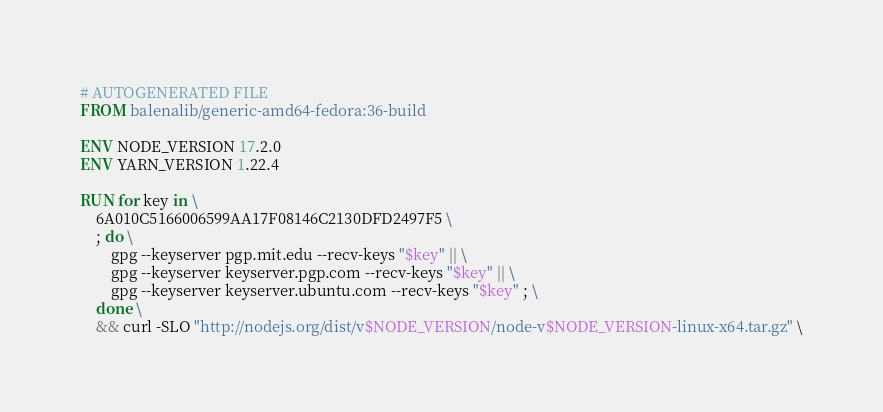<code> <loc_0><loc_0><loc_500><loc_500><_Dockerfile_># AUTOGENERATED FILE
FROM balenalib/generic-amd64-fedora:36-build

ENV NODE_VERSION 17.2.0
ENV YARN_VERSION 1.22.4

RUN for key in \
	6A010C5166006599AA17F08146C2130DFD2497F5 \
	; do \
		gpg --keyserver pgp.mit.edu --recv-keys "$key" || \
		gpg --keyserver keyserver.pgp.com --recv-keys "$key" || \
		gpg --keyserver keyserver.ubuntu.com --recv-keys "$key" ; \
	done \
	&& curl -SLO "http://nodejs.org/dist/v$NODE_VERSION/node-v$NODE_VERSION-linux-x64.tar.gz" \</code> 